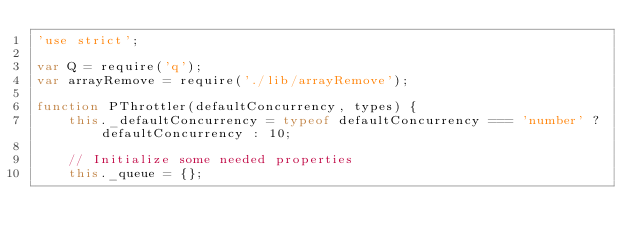Convert code to text. <code><loc_0><loc_0><loc_500><loc_500><_JavaScript_>'use strict';

var Q = require('q');
var arrayRemove = require('./lib/arrayRemove');

function PThrottler(defaultConcurrency, types) {
    this._defaultConcurrency = typeof defaultConcurrency === 'number' ? defaultConcurrency : 10;

    // Initialize some needed properties
    this._queue = {};</code> 